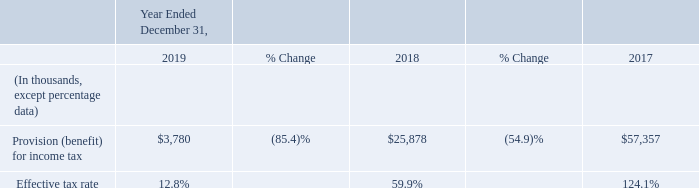2019 vs 2018
The decrease in tax expense for the year ended December 31, 2019, compared to the year ended December 31, 2018, resulted primarily from a decline in pre-tax earnings coupled with favorable benefits from the settlement of international tax audits and changes in estimate in tax expense recorded upon finalizing U.S. tax returns. These benefits were partially offset by the impact of stock based compensation related to shortfalls that occurred during the year as well as the impact of limitations on current and future deductions for certain executive officers under IRC section 162(m).
During fiscal year 2019, the Company evaluated the impact of the Global Intangible Low-Taxed Income “GILTI”, Foreign Derived Intangible Income “FDII” and Base Erosion and Anti-abuse Tax “BEAT” provisions. These provisions resulted in a net addition to tax of $1.7 million. This amount is comprised of BEAT of $2.1 million offset by the impact of GILTI and FDII of $(0.4) million. For fiscal year 2018, the company estimated that these provisions would result on a net benefit of $(0.3) million. Included in the 2019 tax expense is a benefit of $(0.7) million related to the net impact of these provisions as reported on the final U.S. tax return for the year ended December 31, 2018.
2018 vs 2017
The decrease in the effective tax rate and the decrease in tax expense for the year ended December 31, 2018, compared to the year ended December 31, 2017, resulted primarily from the combination of a decline in pre-tax earnings and the decrease in the US federal tax rate from 35% to 21%, and the impact of other provisions of the tax Cuts and Jobs Act. Additionally, tax expense for the year ended December 31, 2017 included the effect of the implementation of certain aspects of the Tax Act including recording provisional expense for the transition tax of $21.7 million for US federal and state income tax purposes. Additionally, the Company recorded tax expense of $26.6 million resulting from the remeasurement of net deferred tax assets resulting from the reduction in US federal tax rate. These items resulted in higher tax expense during fiscal 2017. During fiscal year 2018, the Company completed the computation of the transition tax as part of the 2017 income tax returns filing and reduced the federal and state provisional amount by $6.7 million. The Company has also evaluated the impact of the Global Intangible Low-Taxed Income “GILTI”, Foreign Derived Intangible Income “FDII” and Base Erosion and Anti-abuse Tax “BEAT” provisions and as a result recorded a detriment of $0.4 million and a benefit of $(0.7) million in relation to GILTI and FDII respectively, resulting on a net benefit of $(0.3) million. During the year ended December 31, 2018, the Company recorded tax expense of $23.0 million in continuing operations related to the write-off of deferred tax assets for which the underlying assets and liabilities related to Arlo. The decrease in the effective tax rate and the decrease in tax expense for the year ended December 31, 2018, compared to the year ended December 31, 2017, resulted primarily from the combination of a decline in pre-tax earnings and the decrease in the US federal tax rate from 35% to 21%, and the impact of other provisions of the tax Cuts and Jobs Act. Additionally, tax expense for the year ended December 31, 2017 included the effect of the implementation of certain aspects of the Tax Act including recording provisional expense for the transition tax of $21.7 million for US federal and state income tax purposes. Additionally, the Company recorded tax expense of $26.6 million resulting from the remeasurement of net deferred tax assets resulting from the reduction in US federal tax rate. These items resulted in higher tax expense during fiscal 2017. During fiscal year 2018, the Company completed the computation of the transition tax as part of the 2017 income tax returns filing and reduced the federal and state provisional amount by $6.7 million. The Company has also evaluated the impact of the Global Intangible Low-Taxed Income “GILTI”, Foreign Derived Intangible Income “FDII” and Base Erosion and Anti-abuse Tax “BEAT” provisions and as a result recorded a detriment of $0.4 million and a benefit of $(0.7) million in relation to GILTI and FDII respectively, resulting on a net benefit of $(0.3) million. During the year ended December 31, 2018, the Company recorded tax expense of $23.0 million in continuing operations related to the write-off of deferred tax assets for which the underlying assets and liabilities related to Arlo.
We are subject to income taxes in the U.S. and numerous foreign jurisdictions. Our future foreign tax rate could be affected by changes in the composition in earnings in countries with tax rates differing from the U.S. federal rate. We are under examination in various U.S. and foreign jurisdictions.
What was the change in the US federal tax rate from 2017 to 2018?
Answer scale should be: percent. 21% - 35% 
Answer: -14. What accounted for the decrease in tax expense in 2019? A decline in pre-tax earnings coupled with favorable benefits from the settlement of international tax audits and changes in estimate in tax expense recorded upon finalizing u.s. tax returns. What was the change in effective tax rate from 2018 to 2019?
Answer scale should be: percent. 12.8% - 59.9% 
Answer: -47.1. Which year has the highest provision (benefit) for income taxes? 57,357 > 25,878 > 3,780
Answer: 2017. What resulted in a net addition to tax in 2019? Global intangible low-taxed income “gilti”, foreign derived intangible income “fdii” and base erosion and anti-abuse tax “beat” provisions. What could affect the future foreign tax rate? Changes in the composition in earnings in countries with tax rates differing from the u.s. federal rate. 